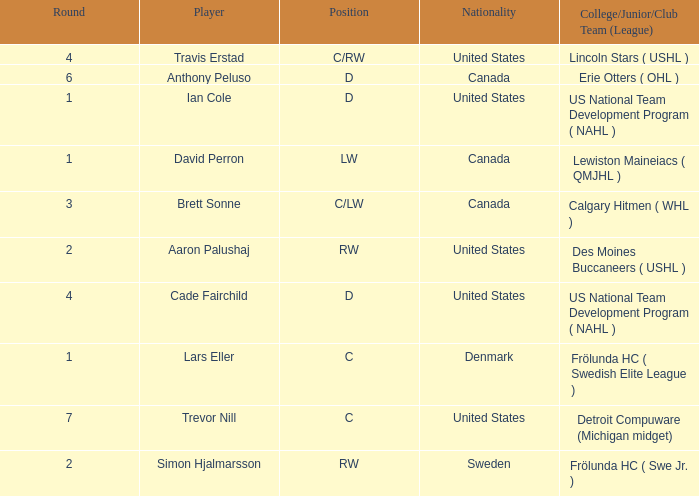Which college/junior/club team (league) did Brett Sonne play in? Calgary Hitmen ( WHL ). 